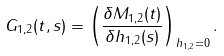Convert formula to latex. <formula><loc_0><loc_0><loc_500><loc_500>G _ { 1 , 2 } ( t , s ) = \left ( \frac { \delta M _ { 1 , 2 } ( t ) } { \delta h _ { 1 , 2 } ( s ) } \right ) _ { h _ { 1 , 2 } = 0 } .</formula> 